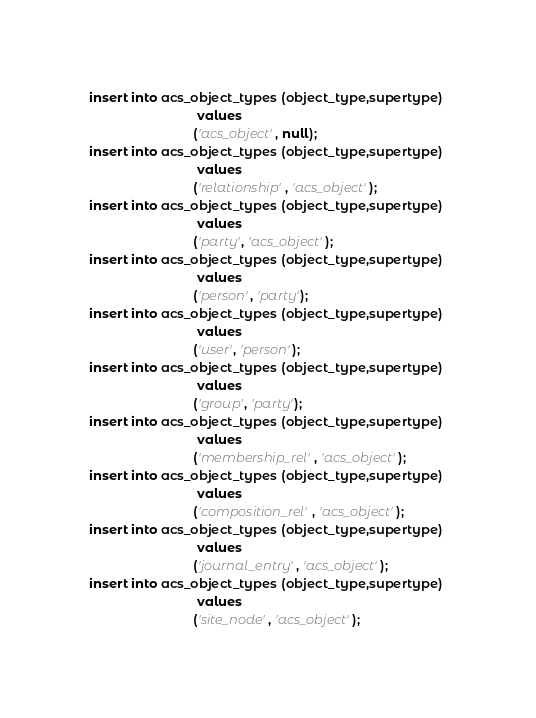Convert code to text. <code><loc_0><loc_0><loc_500><loc_500><_SQL_>


insert into acs_object_types (object_type,supertype) 
                              values 
                             ('acs_object', null);
insert into acs_object_types (object_type,supertype) 
                              values 
                             ('relationship', 'acs_object');
insert into acs_object_types (object_type,supertype) 
                              values 
                             ('party', 'acs_object');
insert into acs_object_types (object_type,supertype) 
                              values 
                             ('person', 'party');
insert into acs_object_types (object_type,supertype) 
                              values 
                             ('user', 'person');
insert into acs_object_types (object_type,supertype) 
                              values 
                             ('group', 'party');
insert into acs_object_types (object_type,supertype) 
                              values 
                             ('membership_rel', 'acs_object');
insert into acs_object_types (object_type,supertype) 
                              values 
                             ('composition_rel', 'acs_object');
insert into acs_object_types (object_type,supertype) 
                              values 
                             ('journal_entry', 'acs_object');
insert into acs_object_types (object_type,supertype) 
                              values 
                             ('site_node', 'acs_object');

</code> 